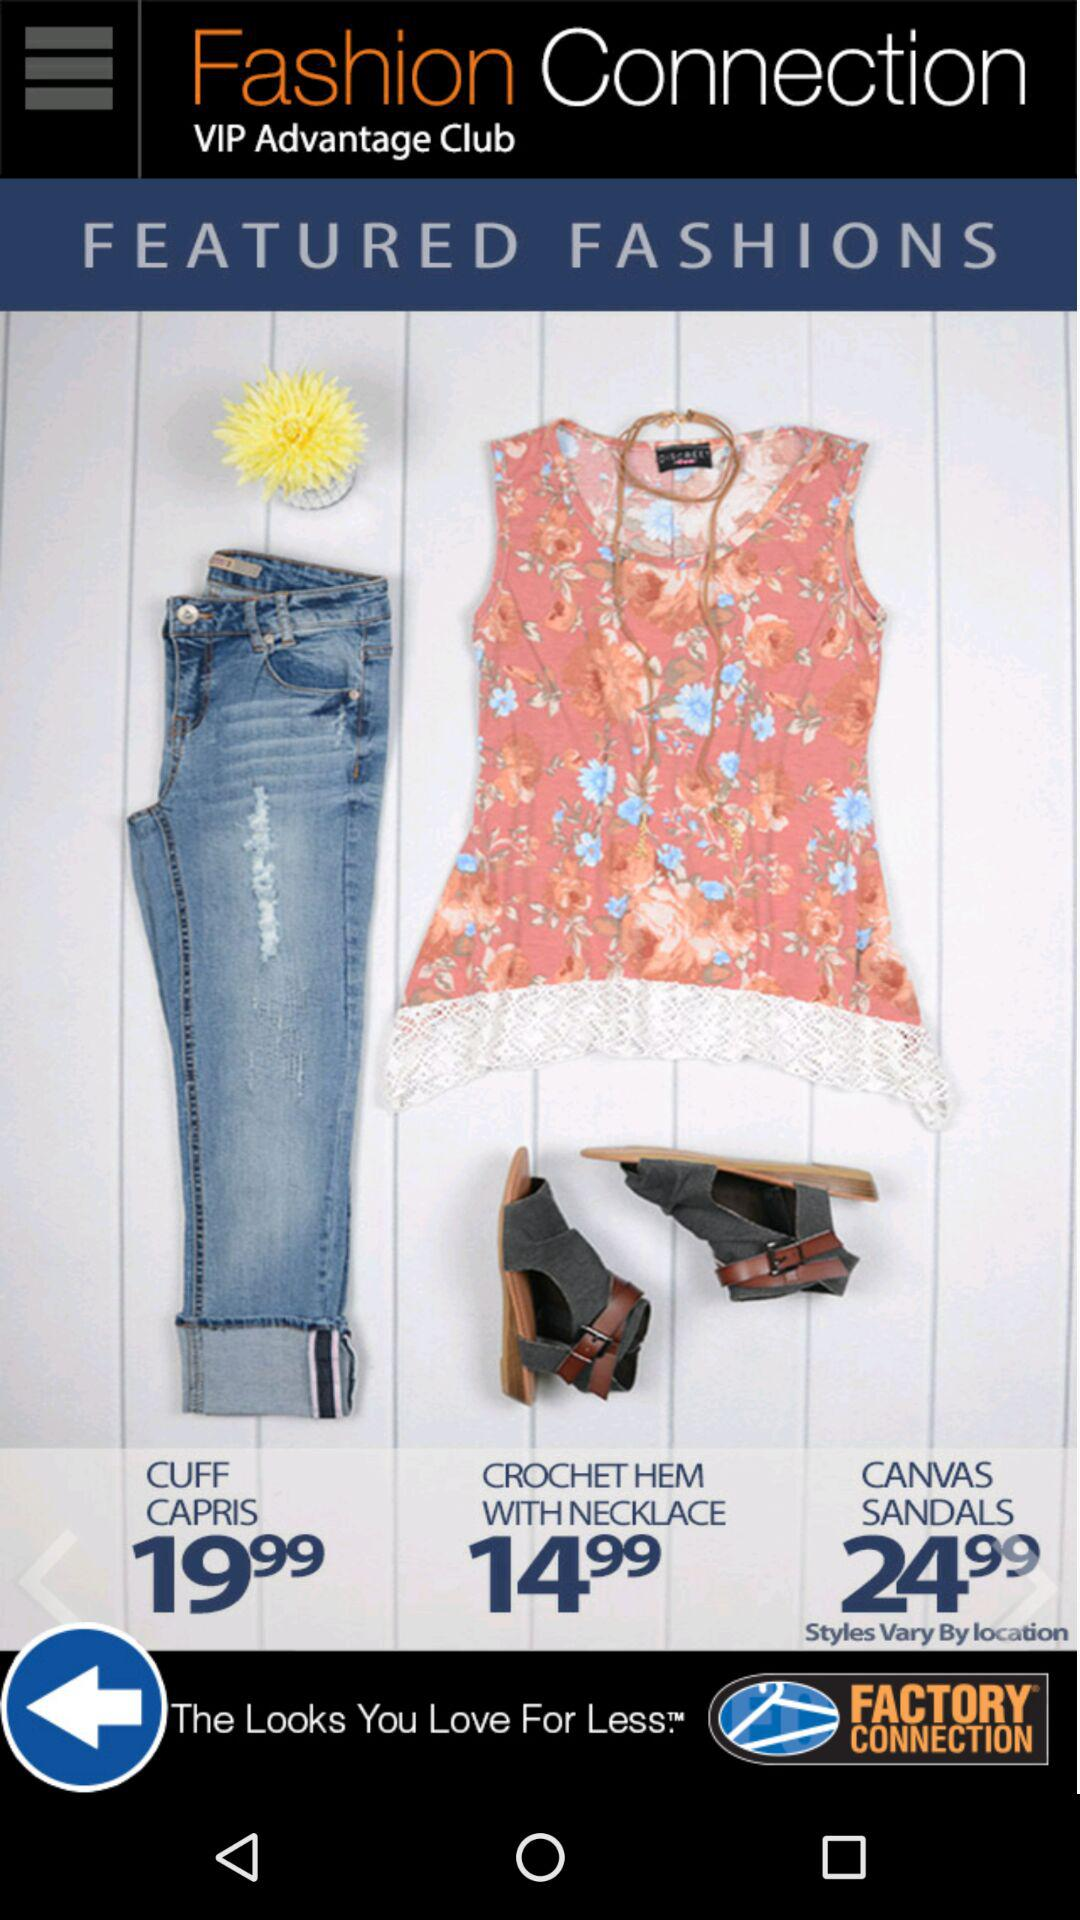How many items are there in the Featured Fashions section?
Answer the question using a single word or phrase. 3 